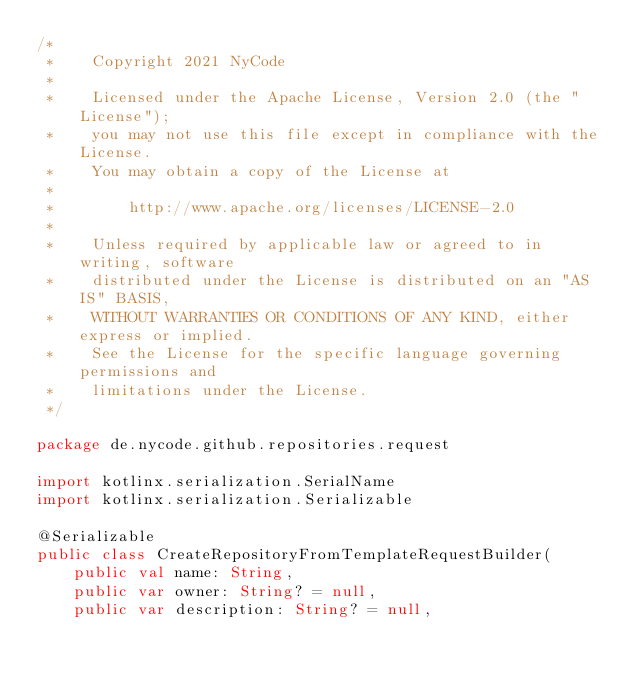Convert code to text. <code><loc_0><loc_0><loc_500><loc_500><_Kotlin_>/*
 *    Copyright 2021 NyCode
 *
 *    Licensed under the Apache License, Version 2.0 (the "License");
 *    you may not use this file except in compliance with the License.
 *    You may obtain a copy of the License at
 *
 *        http://www.apache.org/licenses/LICENSE-2.0
 *
 *    Unless required by applicable law or agreed to in writing, software
 *    distributed under the License is distributed on an "AS IS" BASIS,
 *    WITHOUT WARRANTIES OR CONDITIONS OF ANY KIND, either express or implied.
 *    See the License for the specific language governing permissions and
 *    limitations under the License.
 */

package de.nycode.github.repositories.request

import kotlinx.serialization.SerialName
import kotlinx.serialization.Serializable

@Serializable
public class CreateRepositoryFromTemplateRequestBuilder(
    public val name: String,
    public var owner: String? = null,
    public var description: String? = null,</code> 